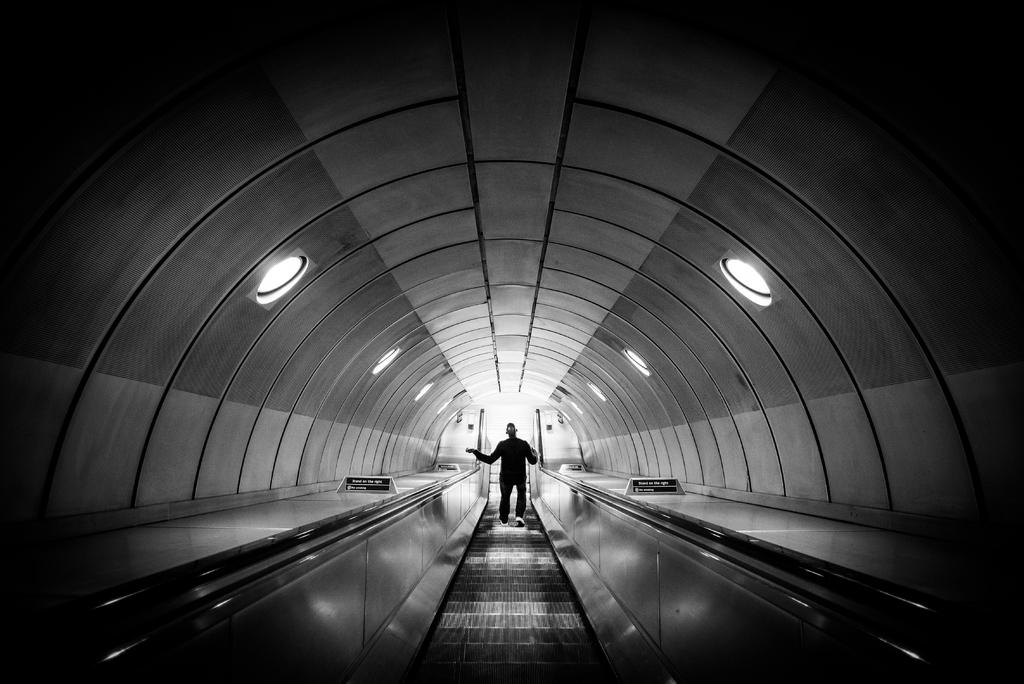What type of structure is present in the image? There is an escalator in the image. Is anyone using the escalator? Yes, a person is on the escalator. What can be seen above the escalator? There is a roof visible in the image. What is attached to the roof? Lights are attached to the roof. What type of feast is being prepared on the escalator? There is no indication of a feast or any food preparation in the image; it only features an escalator with a person on it and a roof with lights attached. 